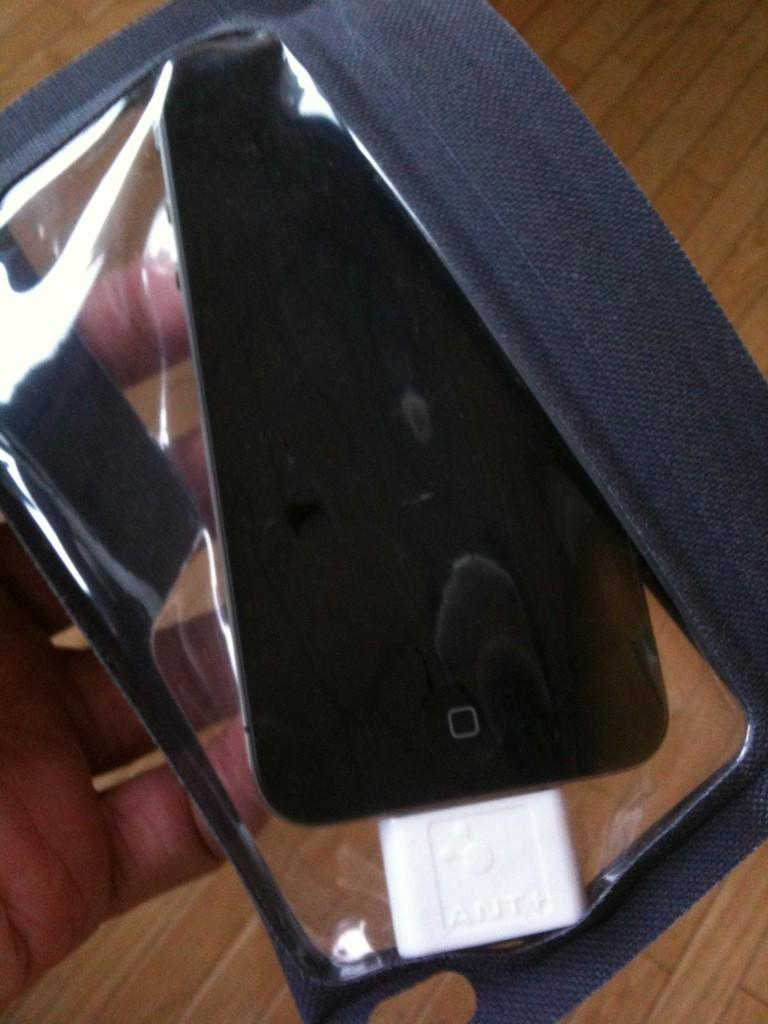What can be seen in the image that belongs to a person? There is a person's hand in the image. What is the person holding in their hand? The person is holding a mobile phone. What additional feature can be seen on the mobile phone? The mobile phone has a cover. What type of surface is visible in the background of the image? There is a wooden surface in the background of the image. Can you see a stream of water flowing in the background of the image? No, there is no stream of water visible in the image. Is there any indication of a payment being made in the image? No, there is no indication of a payment being made in the image. 